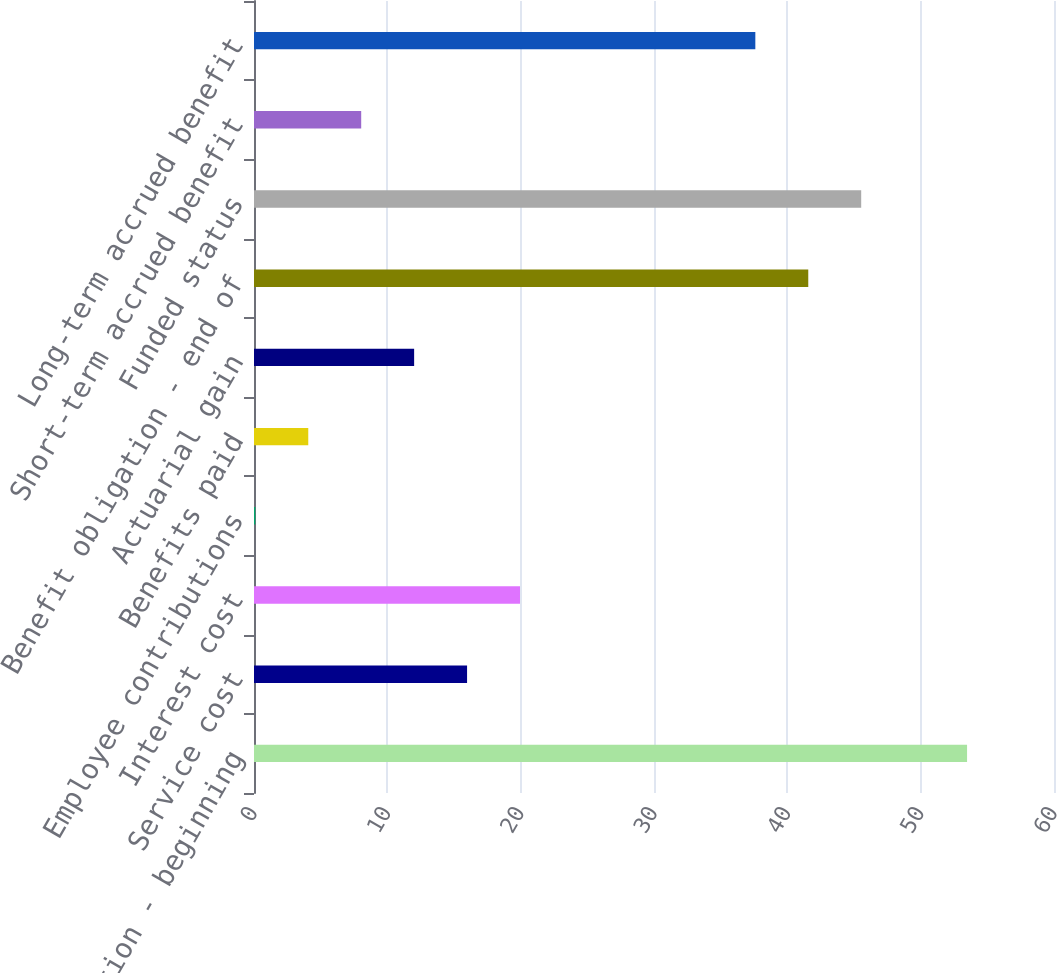<chart> <loc_0><loc_0><loc_500><loc_500><bar_chart><fcel>Benefit obligation - beginning<fcel>Service cost<fcel>Interest cost<fcel>Employee contributions<fcel>Benefits paid<fcel>Actuarial gain<fcel>Benefit obligation - end of<fcel>Funded status<fcel>Short-term accrued benefit<fcel>Long-term accrued benefit<nl><fcel>53.48<fcel>15.98<fcel>19.95<fcel>0.1<fcel>4.07<fcel>12.01<fcel>41.57<fcel>45.54<fcel>8.04<fcel>37.6<nl></chart> 